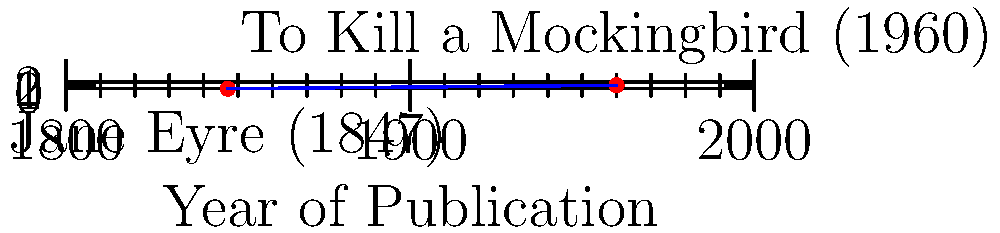Consider the graph showing the publication years of two famous novels: "Jane Eyre" by Charlotte Brontë (1847) and "To Kill a Mockingbird" by Harper Lee (1960). Calculate the slope of the line connecting these two points, where the x-axis represents the year of publication and the y-axis represents an arbitrary scale from 0 to 1. Express your answer as a fraction in its simplest form. To calculate the slope of the line connecting two points, we use the formula:

$$ \text{slope} = \frac{y_2 - y_1}{x_2 - x_1} $$

Where $(x_1, y_1)$ is the first point and $(x_2, y_2)$ is the second point.

1. Identify the coordinates:
   - "Jane Eyre": $(1847, 0)$
   - "To Kill a Mockingbird": $(1960, 1)$

2. Plug these values into the slope formula:
   $$ \text{slope} = \frac{1 - 0}{1960 - 1847} = \frac{1}{113} $$

3. The fraction $\frac{1}{113}$ is already in its simplest form, as 1 and 113 have no common factors other than 1.

Therefore, the slope of the line connecting the two points is $\frac{1}{113}$.
Answer: $\frac{1}{113}$ 